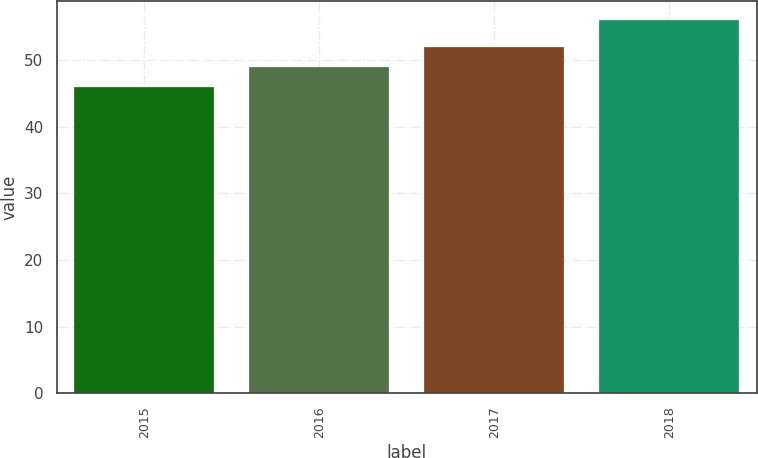<chart> <loc_0><loc_0><loc_500><loc_500><bar_chart><fcel>2015<fcel>2016<fcel>2017<fcel>2018<nl><fcel>46<fcel>49<fcel>52<fcel>56<nl></chart> 